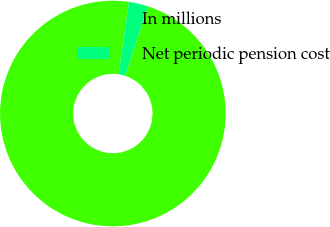Convert chart to OTSL. <chart><loc_0><loc_0><loc_500><loc_500><pie_chart><fcel>In millions<fcel>Net periodic pension cost<nl><fcel>97.25%<fcel>2.75%<nl></chart> 